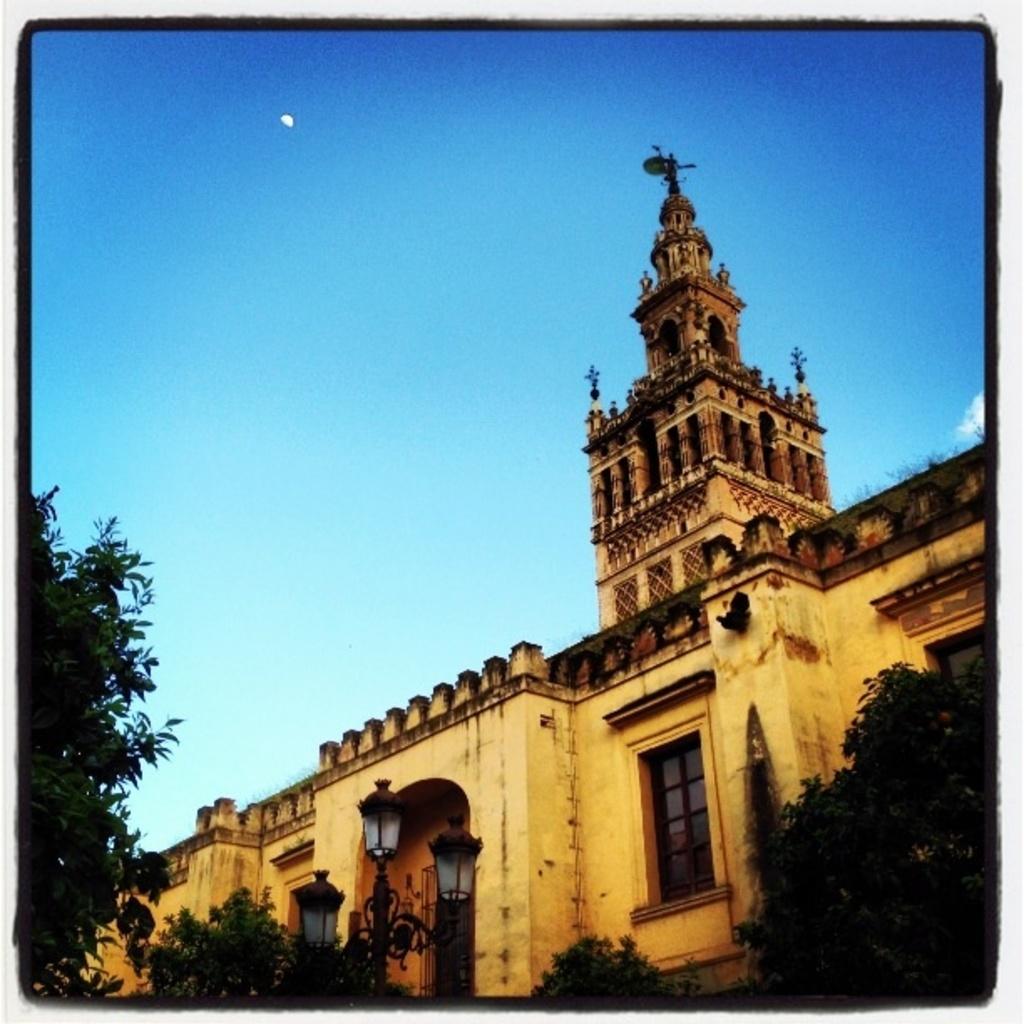Please provide a concise description of this image. This is an edited picture. I can see trees, lights, there is a building, and in the background there is sky. 